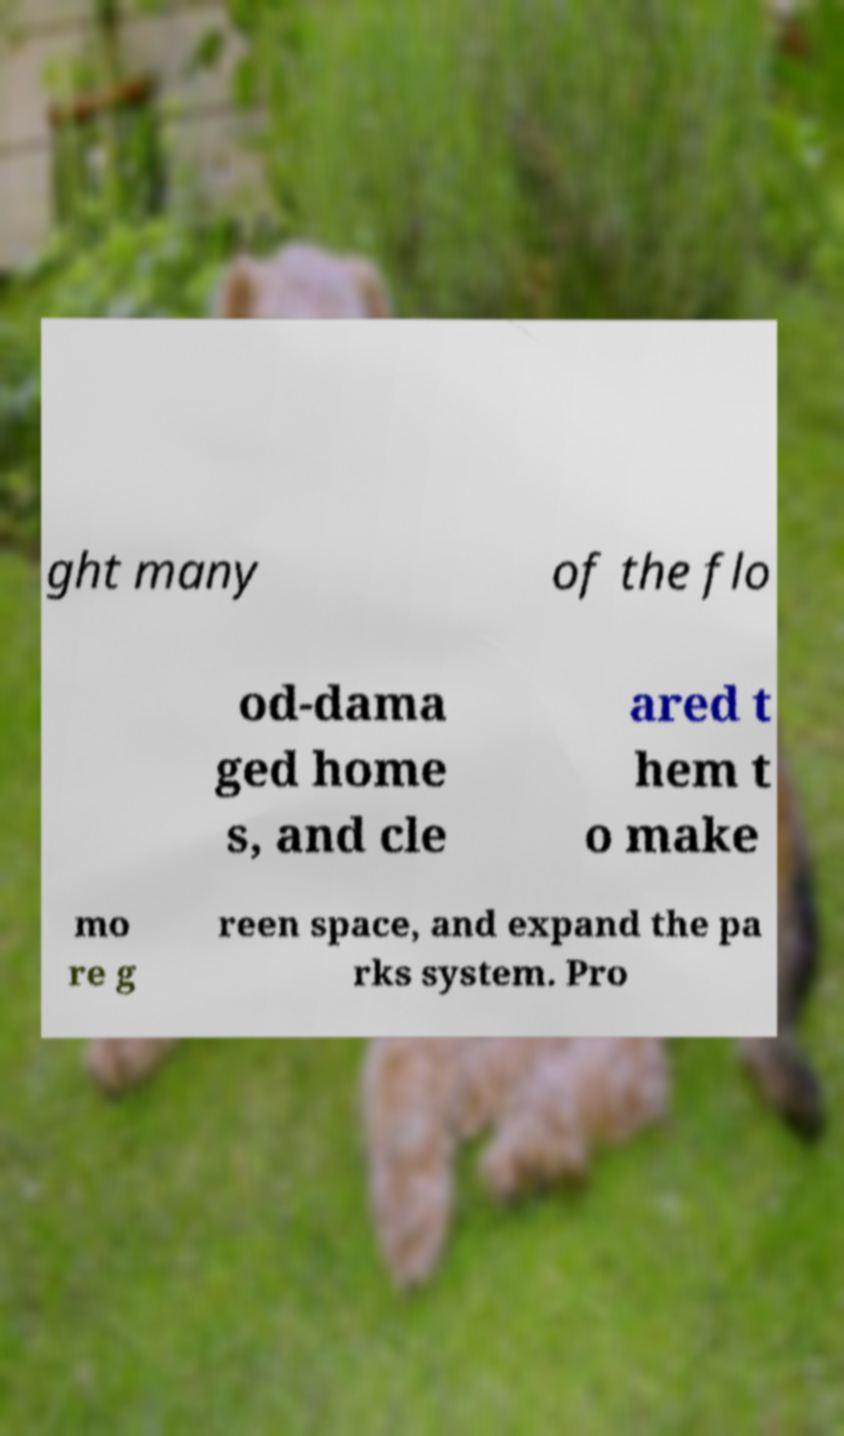Could you assist in decoding the text presented in this image and type it out clearly? ght many of the flo od-dama ged home s, and cle ared t hem t o make mo re g reen space, and expand the pa rks system. Pro 